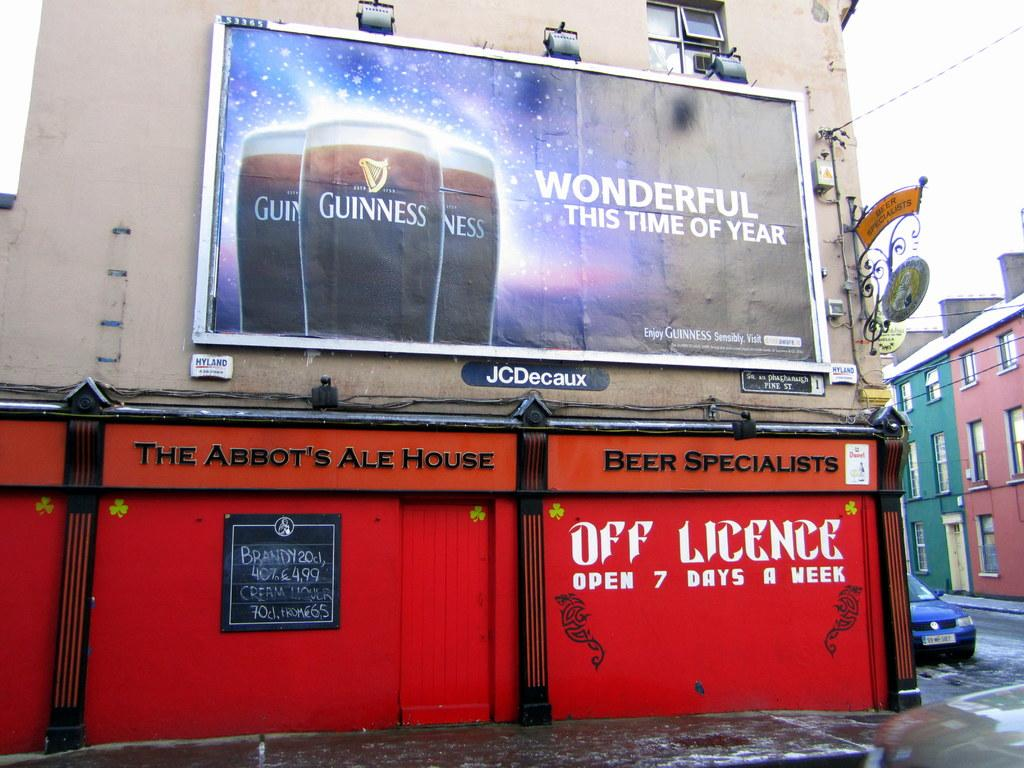<image>
Describe the image concisely. A billboard above a building that says The Abbot's Ale House. 